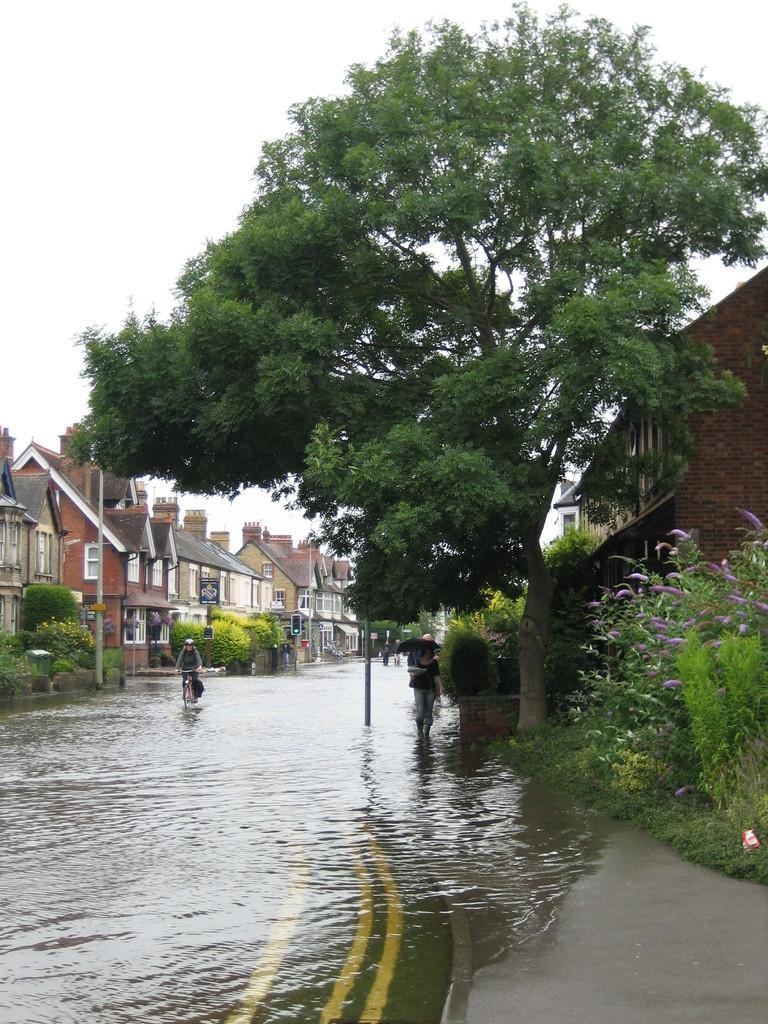Describe this image in one or two sentences. In this image in the center there is water on the road and there is a person riding a bicycle in the background. On the right side there is a person walking holding an umbrella and on the right side there are plants there is grass on the ground and there are buildings and there is a tree. In the background there are houses and there are plants. 